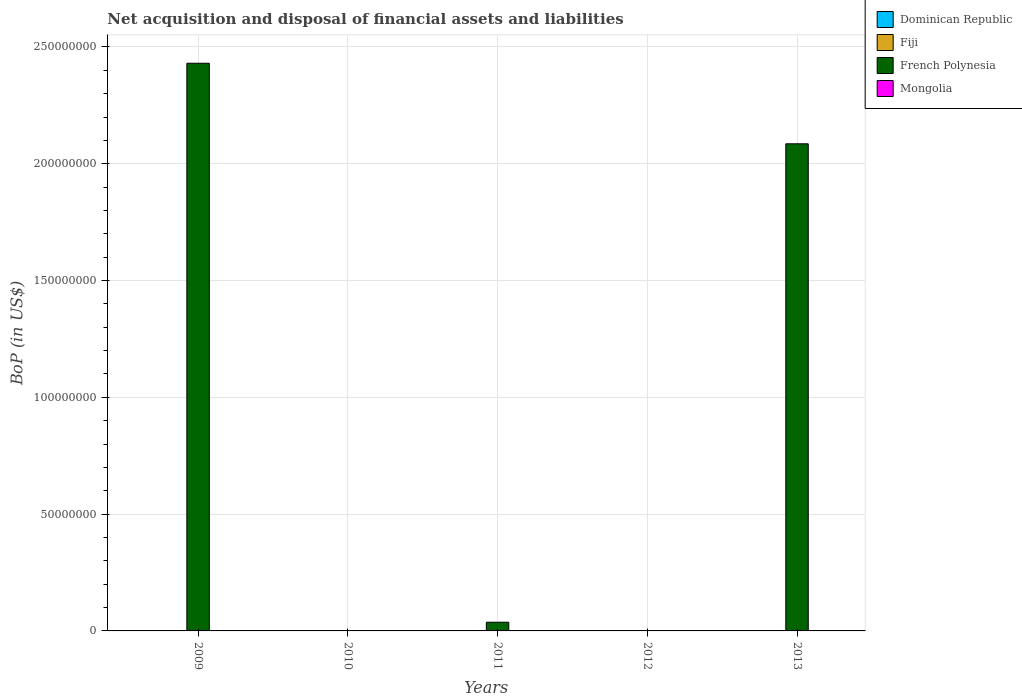Are the number of bars per tick equal to the number of legend labels?
Ensure brevity in your answer.  No. How many bars are there on the 4th tick from the left?
Make the answer very short. 0. In how many cases, is the number of bars for a given year not equal to the number of legend labels?
Provide a succinct answer. 5. Across all years, what is the maximum Balance of Payments in French Polynesia?
Keep it short and to the point. 2.43e+08. Across all years, what is the minimum Balance of Payments in French Polynesia?
Give a very brief answer. 0. In which year was the Balance of Payments in French Polynesia maximum?
Ensure brevity in your answer.  2009. What is the total Balance of Payments in Dominican Republic in the graph?
Ensure brevity in your answer.  0. What is the difference between the Balance of Payments in French Polynesia in 2009 and that in 2011?
Give a very brief answer. 2.39e+08. What is the average Balance of Payments in French Polynesia per year?
Provide a succinct answer. 9.11e+07. In how many years, is the Balance of Payments in French Polynesia greater than 210000000 US$?
Provide a succinct answer. 1. What is the difference between the highest and the second highest Balance of Payments in French Polynesia?
Offer a very short reply. 3.45e+07. What is the difference between the highest and the lowest Balance of Payments in French Polynesia?
Ensure brevity in your answer.  2.43e+08. In how many years, is the Balance of Payments in Dominican Republic greater than the average Balance of Payments in Dominican Republic taken over all years?
Provide a succinct answer. 0. Is it the case that in every year, the sum of the Balance of Payments in French Polynesia and Balance of Payments in Mongolia is greater than the sum of Balance of Payments in Fiji and Balance of Payments in Dominican Republic?
Offer a terse response. No. Is it the case that in every year, the sum of the Balance of Payments in Mongolia and Balance of Payments in French Polynesia is greater than the Balance of Payments in Dominican Republic?
Offer a very short reply. No. How many bars are there?
Offer a terse response. 3. What is the difference between two consecutive major ticks on the Y-axis?
Offer a terse response. 5.00e+07. Are the values on the major ticks of Y-axis written in scientific E-notation?
Ensure brevity in your answer.  No. Does the graph contain any zero values?
Your answer should be very brief. Yes. Where does the legend appear in the graph?
Your answer should be very brief. Top right. How many legend labels are there?
Ensure brevity in your answer.  4. What is the title of the graph?
Offer a terse response. Net acquisition and disposal of financial assets and liabilities. Does "Bahamas" appear as one of the legend labels in the graph?
Your answer should be very brief. No. What is the label or title of the Y-axis?
Provide a short and direct response. BoP (in US$). What is the BoP (in US$) of Dominican Republic in 2009?
Your answer should be compact. 0. What is the BoP (in US$) of French Polynesia in 2009?
Your response must be concise. 2.43e+08. What is the BoP (in US$) of Mongolia in 2009?
Make the answer very short. 0. What is the BoP (in US$) of Dominican Republic in 2010?
Offer a terse response. 0. What is the BoP (in US$) of French Polynesia in 2010?
Your response must be concise. 0. What is the BoP (in US$) in Mongolia in 2010?
Keep it short and to the point. 0. What is the BoP (in US$) in French Polynesia in 2011?
Offer a very short reply. 3.72e+06. What is the BoP (in US$) of Mongolia in 2011?
Give a very brief answer. 0. What is the BoP (in US$) in Dominican Republic in 2012?
Make the answer very short. 0. What is the BoP (in US$) of Fiji in 2012?
Give a very brief answer. 0. What is the BoP (in US$) in French Polynesia in 2012?
Provide a succinct answer. 0. What is the BoP (in US$) of Dominican Republic in 2013?
Provide a short and direct response. 0. What is the BoP (in US$) of Fiji in 2013?
Make the answer very short. 0. What is the BoP (in US$) in French Polynesia in 2013?
Give a very brief answer. 2.09e+08. Across all years, what is the maximum BoP (in US$) of French Polynesia?
Your answer should be compact. 2.43e+08. Across all years, what is the minimum BoP (in US$) of French Polynesia?
Give a very brief answer. 0. What is the total BoP (in US$) in French Polynesia in the graph?
Provide a succinct answer. 4.55e+08. What is the total BoP (in US$) in Mongolia in the graph?
Your answer should be compact. 0. What is the difference between the BoP (in US$) of French Polynesia in 2009 and that in 2011?
Your response must be concise. 2.39e+08. What is the difference between the BoP (in US$) of French Polynesia in 2009 and that in 2013?
Make the answer very short. 3.45e+07. What is the difference between the BoP (in US$) in French Polynesia in 2011 and that in 2013?
Make the answer very short. -2.05e+08. What is the average BoP (in US$) in Dominican Republic per year?
Your response must be concise. 0. What is the average BoP (in US$) in Fiji per year?
Make the answer very short. 0. What is the average BoP (in US$) of French Polynesia per year?
Offer a very short reply. 9.11e+07. What is the ratio of the BoP (in US$) in French Polynesia in 2009 to that in 2011?
Offer a terse response. 65.34. What is the ratio of the BoP (in US$) in French Polynesia in 2009 to that in 2013?
Offer a terse response. 1.17. What is the ratio of the BoP (in US$) of French Polynesia in 2011 to that in 2013?
Give a very brief answer. 0.02. What is the difference between the highest and the second highest BoP (in US$) of French Polynesia?
Your answer should be very brief. 3.45e+07. What is the difference between the highest and the lowest BoP (in US$) of French Polynesia?
Offer a very short reply. 2.43e+08. 